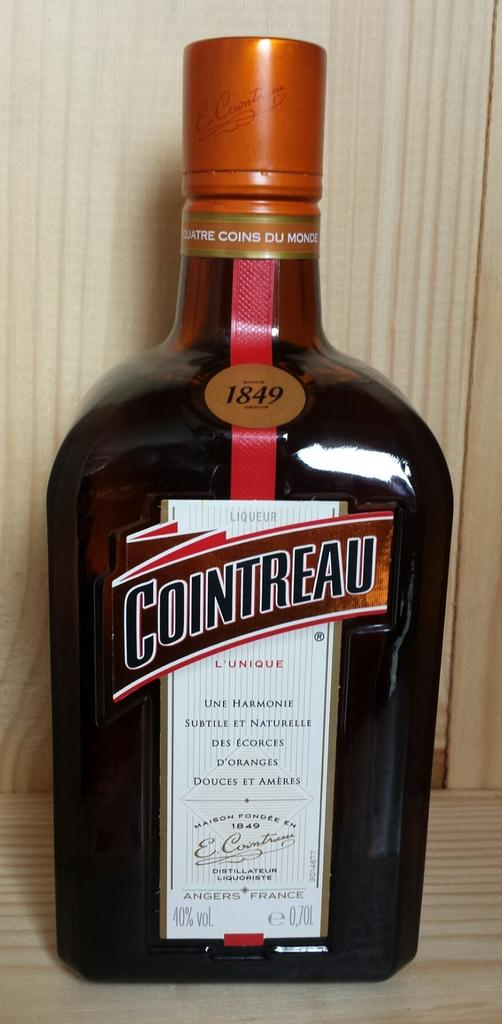<image>
Describe the image concisely. A bottle of liqueur that is named COINTREAU. 